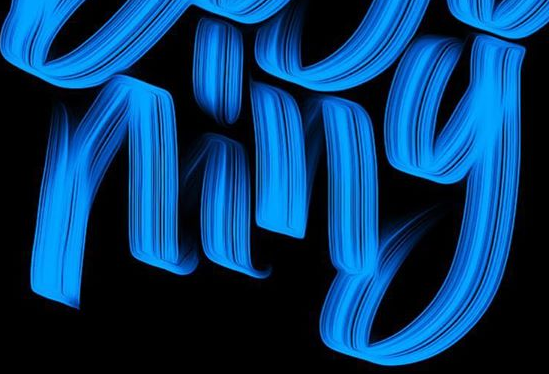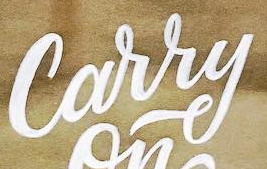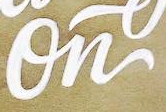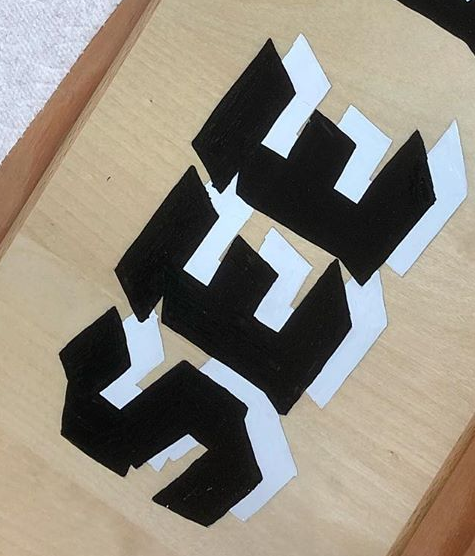Identify the words shown in these images in order, separated by a semicolon. ning; Carry; On; SEE 